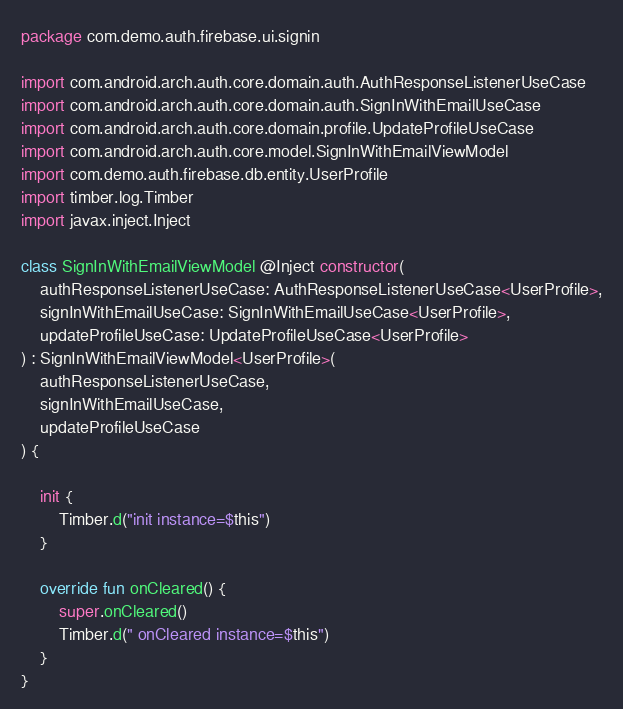<code> <loc_0><loc_0><loc_500><loc_500><_Kotlin_>package com.demo.auth.firebase.ui.signin

import com.android.arch.auth.core.domain.auth.AuthResponseListenerUseCase
import com.android.arch.auth.core.domain.auth.SignInWithEmailUseCase
import com.android.arch.auth.core.domain.profile.UpdateProfileUseCase
import com.android.arch.auth.core.model.SignInWithEmailViewModel
import com.demo.auth.firebase.db.entity.UserProfile
import timber.log.Timber
import javax.inject.Inject

class SignInWithEmailViewModel @Inject constructor(
    authResponseListenerUseCase: AuthResponseListenerUseCase<UserProfile>,
    signInWithEmailUseCase: SignInWithEmailUseCase<UserProfile>,
    updateProfileUseCase: UpdateProfileUseCase<UserProfile>
) : SignInWithEmailViewModel<UserProfile>(
    authResponseListenerUseCase,
    signInWithEmailUseCase,
    updateProfileUseCase
) {

    init {
        Timber.d("init instance=$this")
    }

    override fun onCleared() {
        super.onCleared()
        Timber.d(" onCleared instance=$this")
    }
}</code> 